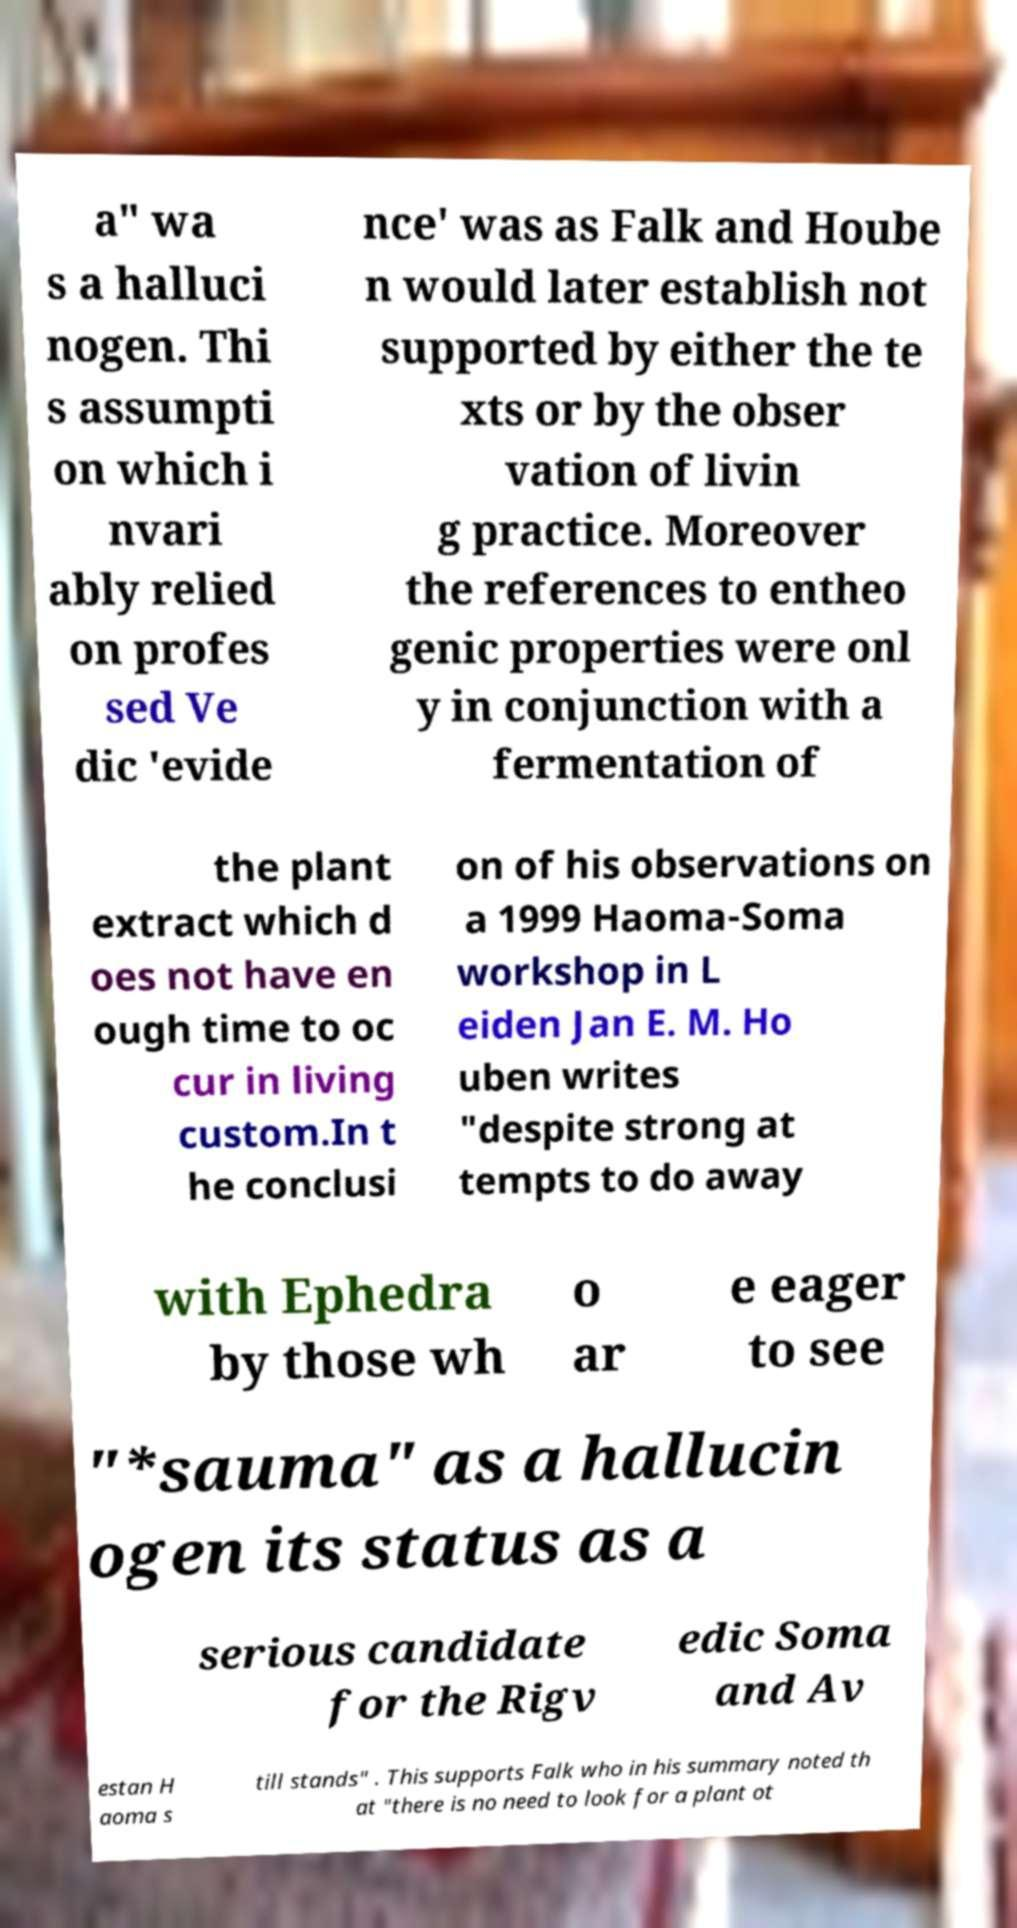What messages or text are displayed in this image? I need them in a readable, typed format. a" wa s a halluci nogen. Thi s assumpti on which i nvari ably relied on profes sed Ve dic 'evide nce' was as Falk and Hoube n would later establish not supported by either the te xts or by the obser vation of livin g practice. Moreover the references to entheo genic properties were onl y in conjunction with a fermentation of the plant extract which d oes not have en ough time to oc cur in living custom.In t he conclusi on of his observations on a 1999 Haoma-Soma workshop in L eiden Jan E. M. Ho uben writes "despite strong at tempts to do away with Ephedra by those wh o ar e eager to see "*sauma" as a hallucin ogen its status as a serious candidate for the Rigv edic Soma and Av estan H aoma s till stands" . This supports Falk who in his summary noted th at "there is no need to look for a plant ot 